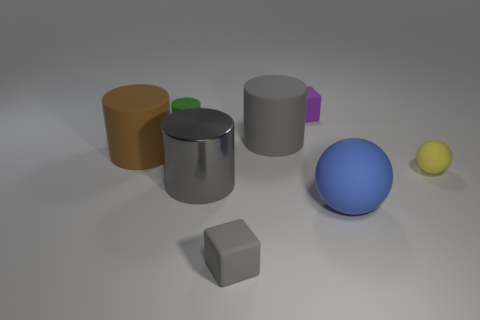Are there fewer yellow things than big blue matte cubes?
Make the answer very short. No. What number of other things are there of the same color as the small sphere?
Offer a terse response. 0. How many small red matte cylinders are there?
Keep it short and to the point. 0. Is the number of small green matte cylinders on the right side of the small purple thing less than the number of red balls?
Offer a terse response. No. Are the cube in front of the big blue rubber sphere and the brown cylinder made of the same material?
Provide a succinct answer. Yes. What is the shape of the gray thing that is in front of the large sphere right of the rubber cube that is to the left of the purple rubber block?
Your answer should be very brief. Cube. Is there a brown sphere that has the same size as the yellow sphere?
Keep it short and to the point. No. What is the size of the blue ball?
Your response must be concise. Large. How many purple rubber things have the same size as the green rubber object?
Provide a short and direct response. 1. Are there fewer rubber things in front of the tiny purple matte thing than purple things behind the blue rubber thing?
Offer a very short reply. No. 